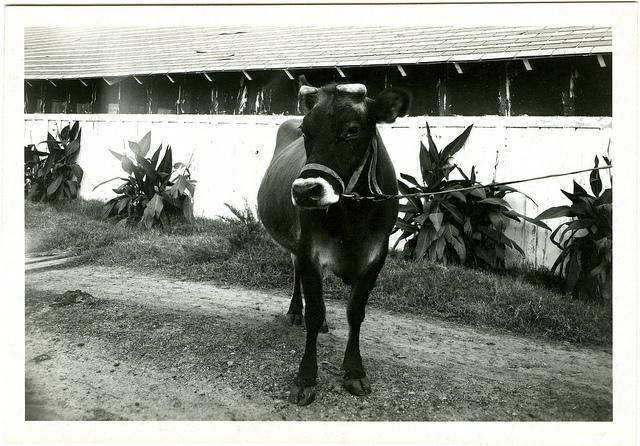How many cows can be seen?
Give a very brief answer. 1. How many potted plants are in the photo?
Give a very brief answer. 3. 